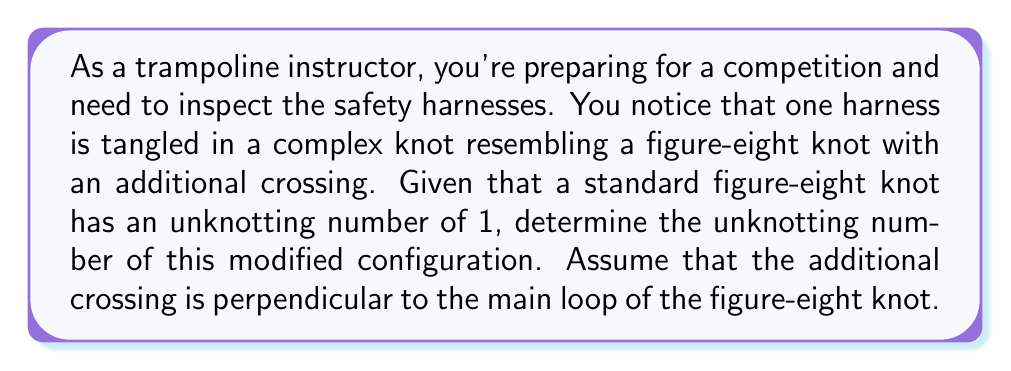What is the answer to this math problem? To solve this problem, let's follow these steps:

1. Recall that the unknotting number is the minimum number of crossing changes required to transform a knot into the unknot (trivial knot).

2. A standard figure-eight knot has an unknotting number of 1. This means that changing any one of its crossings will result in the unknot.

3. The given configuration is described as a figure-eight knot with an additional crossing. Let's analyze how this affects the unknotting number:

   a. The original figure-eight knot requires one crossing change to unknot.
   b. The additional crossing is perpendicular to the main loop, which means it's not part of the essential structure of the figure-eight knot.

4. To unknot this configuration, we need to:
   a. Change one crossing of the original figure-eight knot (1 move)
   b. Undo the additional crossing (1 move)

5. Therefore, the minimum number of crossing changes required is 1 + 1 = 2.

6. By definition, this minimum number of crossing changes is the unknotting number of the given configuration.

Thus, the unknotting number of the modified figure-eight knot with an additional crossing is 2.
Answer: 2 